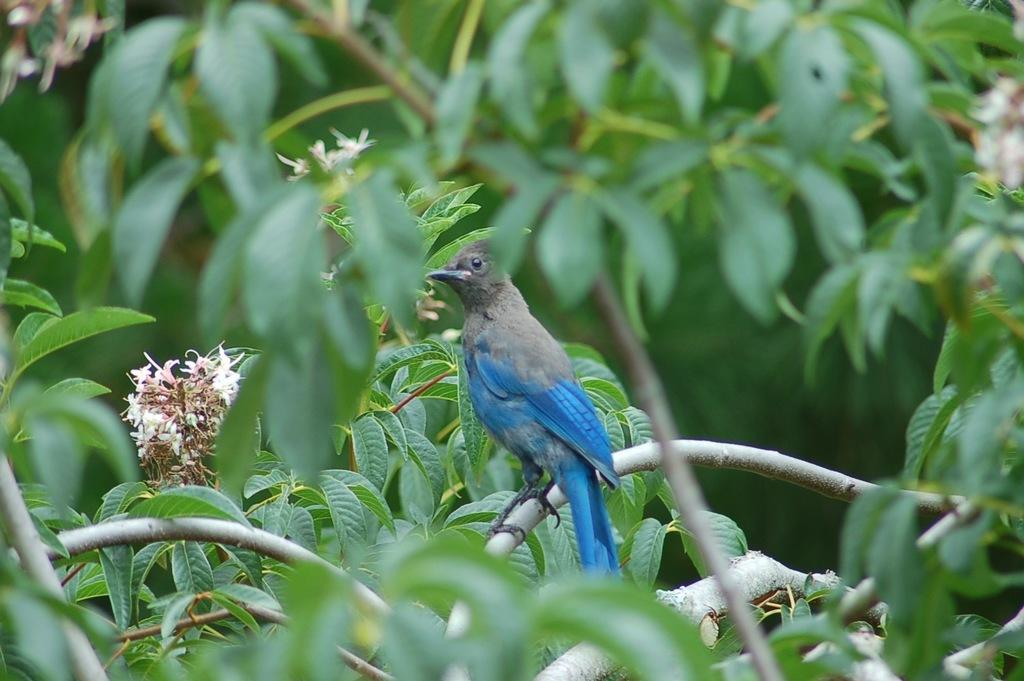What type of animal is in the image? There is a bird in the image. Where is the bird located? The bird is sitting on a branch of a plant. What can be seen in the background of the image? There are flower plants in the background of the image. What color are the flowers? The flowers are white in color. What reason does the bird have for being in the bedroom in the image? There is no bedroom present in the image, and the bird is not in a bedroom; it is sitting on a branch of a plant. 